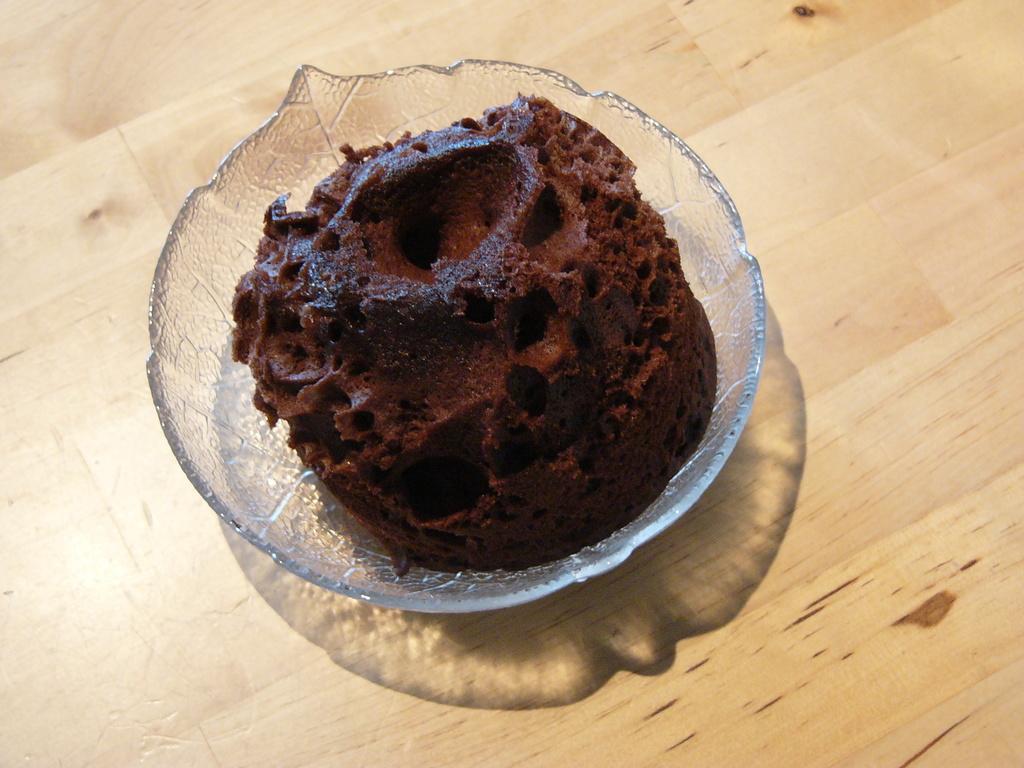Describe this image in one or two sentences. In this picture we can see a food item in a glass bowl. This glass bowl is on a wooden surface. 